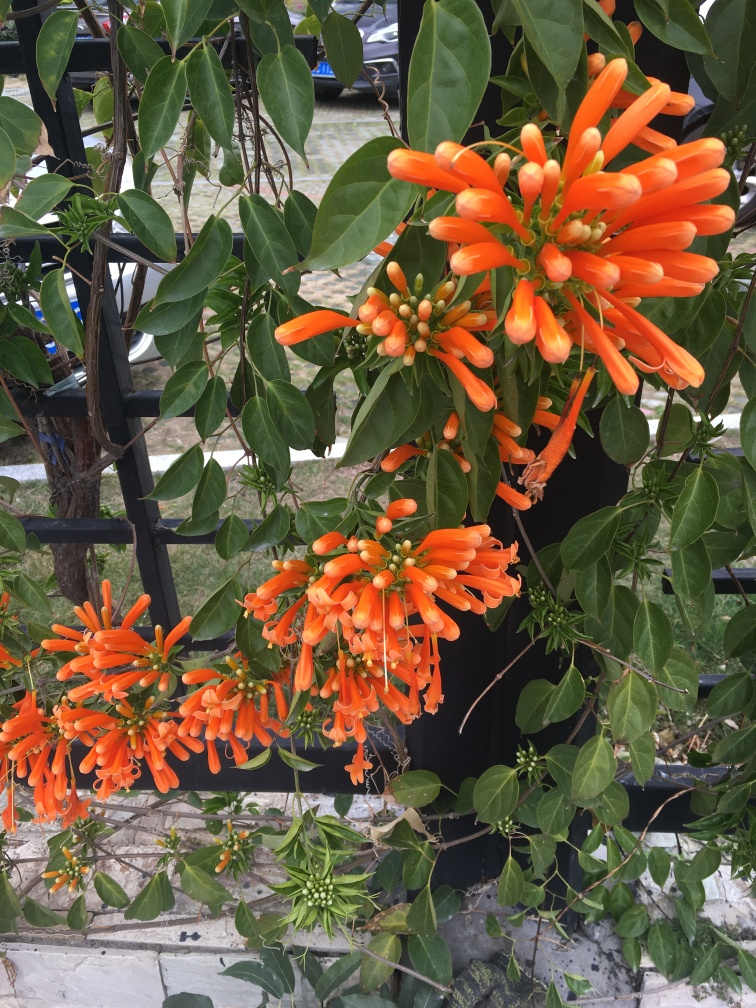How is the lighting in the image?
A. overexposed
B. sufficient
C. harsh
D. uneven
Answer with the option's letter from the given choices directly.
 B. 